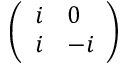<formula> <loc_0><loc_0><loc_500><loc_500>\left ( \begin{array} { l l } { i } & { 0 } \\ { i } & { - i } \end{array} \right )</formula> 